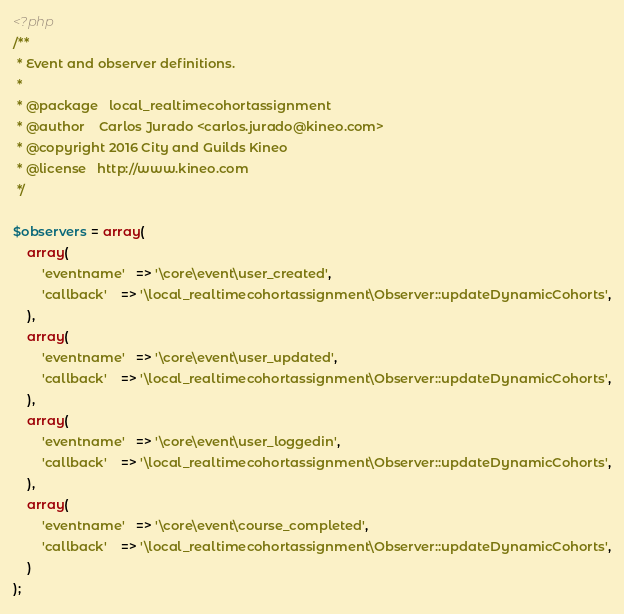<code> <loc_0><loc_0><loc_500><loc_500><_PHP_><?php
/**
 * Event and observer definitions.
 *
 * @package   local_realtimecohortassignment
 * @author    Carlos Jurado <carlos.jurado@kineo.com>
 * @copyright 2016 City and Guilds Kineo
 * @license   http://www.kineo.com
 */

$observers = array(
    array(
        'eventname'   => '\core\event\user_created',
        'callback'    => '\local_realtimecohortassignment\Observer::updateDynamicCohorts',
    ),
    array(
        'eventname'   => '\core\event\user_updated',
        'callback'    => '\local_realtimecohortassignment\Observer::updateDynamicCohorts',
    ),
    array(
        'eventname'   => '\core\event\user_loggedin',
        'callback'    => '\local_realtimecohortassignment\Observer::updateDynamicCohorts',
    ),
    array(
        'eventname'   => '\core\event\course_completed',
        'callback'    => '\local_realtimecohortassignment\Observer::updateDynamicCohorts',
    )
);</code> 